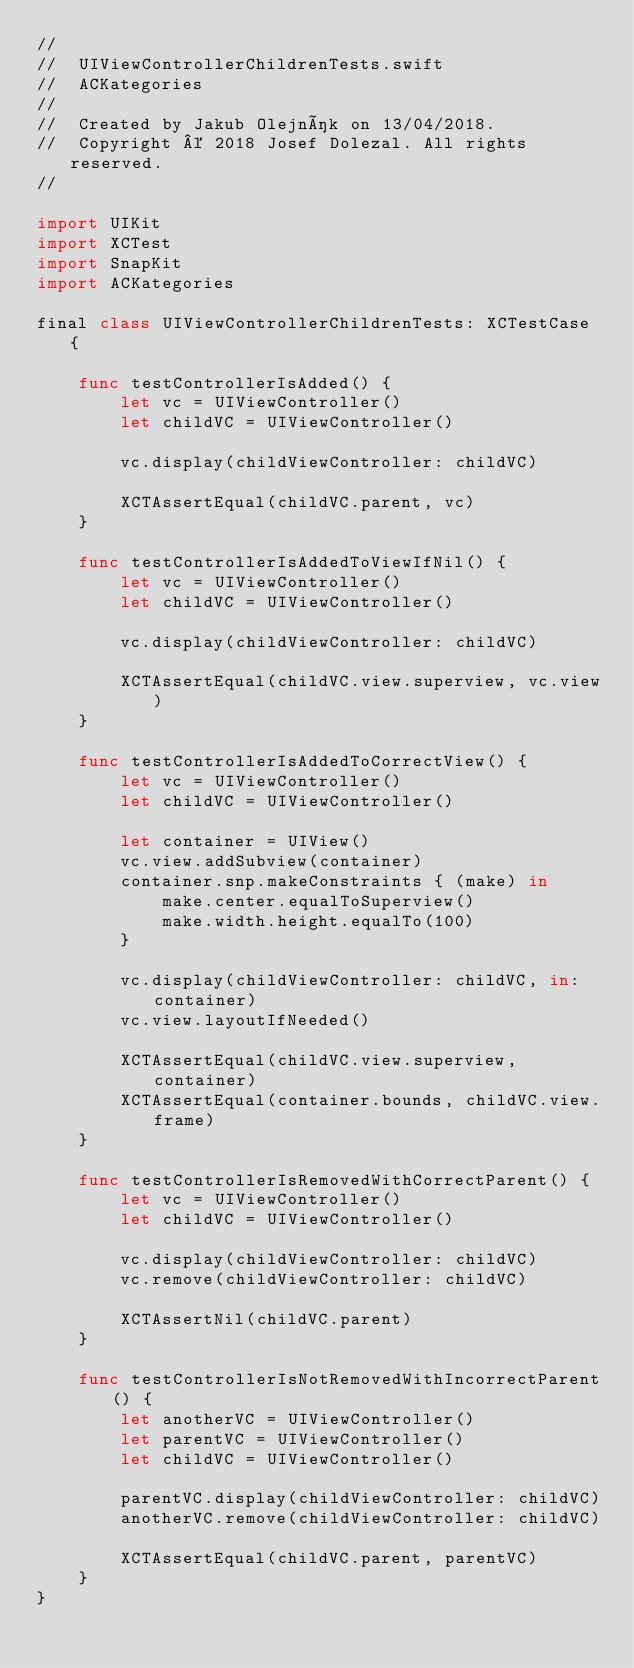<code> <loc_0><loc_0><loc_500><loc_500><_Swift_>//
//  UIViewControllerChildrenTests.swift
//  ACKategories
//
//  Created by Jakub Olejník on 13/04/2018.
//  Copyright © 2018 Josef Dolezal. All rights reserved.
//

import UIKit
import XCTest
import SnapKit
import ACKategories

final class UIViewControllerChildrenTests: XCTestCase {
    
    func testControllerIsAdded() {
        let vc = UIViewController()
        let childVC = UIViewController()
        
        vc.display(childViewController: childVC)
        
        XCTAssertEqual(childVC.parent, vc)
    }
    
    func testControllerIsAddedToViewIfNil() {
        let vc = UIViewController()
        let childVC = UIViewController()
        
        vc.display(childViewController: childVC)
        
        XCTAssertEqual(childVC.view.superview, vc.view)
    }
    
    func testControllerIsAddedToCorrectView() {
        let vc = UIViewController()
        let childVC = UIViewController()
        
        let container = UIView()
        vc.view.addSubview(container)
        container.snp.makeConstraints { (make) in
            make.center.equalToSuperview()
            make.width.height.equalTo(100)
        }
        
        vc.display(childViewController: childVC, in: container)
        vc.view.layoutIfNeeded()
        
        XCTAssertEqual(childVC.view.superview, container)
        XCTAssertEqual(container.bounds, childVC.view.frame)
    }
    
    func testControllerIsRemovedWithCorrectParent() {
        let vc = UIViewController()
        let childVC = UIViewController()
        
        vc.display(childViewController: childVC)
        vc.remove(childViewController: childVC)
        
        XCTAssertNil(childVC.parent)
    }
    
    func testControllerIsNotRemovedWithIncorrectParent() {
        let anotherVC = UIViewController()
        let parentVC = UIViewController()
        let childVC = UIViewController()
        
        parentVC.display(childViewController: childVC)
        anotherVC.remove(childViewController: childVC)
        
        XCTAssertEqual(childVC.parent, parentVC)
    }
}
</code> 